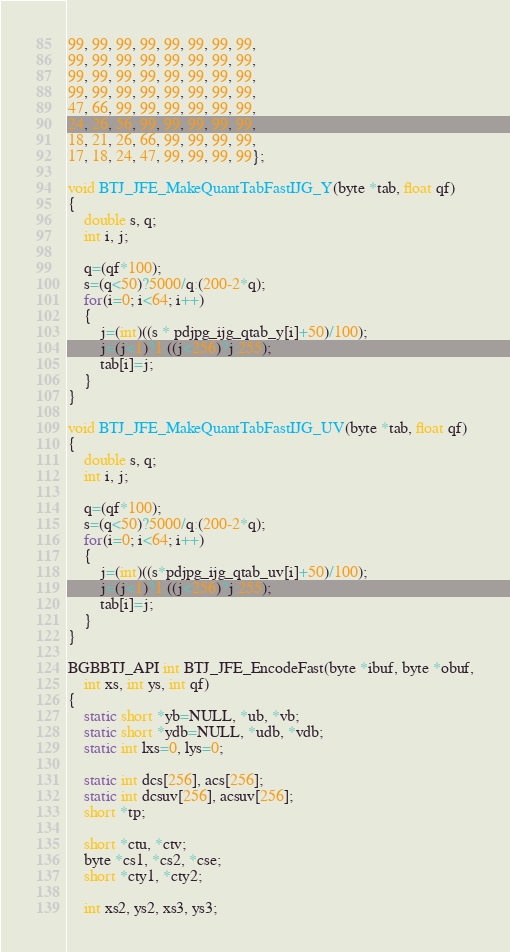<code> <loc_0><loc_0><loc_500><loc_500><_C_>99, 99, 99, 99, 99, 99, 99, 99,
99, 99, 99, 99, 99, 99, 99, 99,
99, 99, 99, 99, 99, 99, 99, 99,
99, 99, 99, 99, 99, 99, 99, 99,
47, 66, 99, 99, 99, 99, 99, 99,
24, 26, 56, 99, 99, 99, 99, 99,
18, 21, 26, 66, 99, 99, 99, 99,
17, 18, 24, 47, 99, 99, 99, 99};

void BTJ_JFE_MakeQuantTabFastIJG_Y(byte *tab, float qf)
{
	double s, q;
	int i, j;

	q=(qf*100);
	s=(q<50)?5000/q:(200-2*q);
	for(i=0; i<64; i++)
	{
		j=(int)((s * pdjpg_ijg_qtab_y[i]+50)/100);
		j=(j<1)?1:((j<256)?j:255);
		tab[i]=j;
	}
}

void BTJ_JFE_MakeQuantTabFastIJG_UV(byte *tab, float qf)
{
	double s, q;
	int i, j;

	q=(qf*100);
	s=(q<50)?5000/q:(200-2*q);
	for(i=0; i<64; i++)
	{
		j=(int)((s*pdjpg_ijg_qtab_uv[i]+50)/100);
		j=(j<1)?1:((j<256)?j:255);
		tab[i]=j;
	}
}

BGBBTJ_API int BTJ_JFE_EncodeFast(byte *ibuf, byte *obuf,
	int xs, int ys, int qf)
{
	static short *yb=NULL, *ub, *vb;
	static short *ydb=NULL, *udb, *vdb;
	static int lxs=0, lys=0;

	static int dcs[256], acs[256];
	static int dcsuv[256], acsuv[256];
	short *tp;

	short *ctu, *ctv;
	byte *cs1, *cs2, *cse;
	short *cty1, *cty2;

	int xs2, ys2, xs3, ys3;</code> 